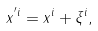Convert formula to latex. <formula><loc_0><loc_0><loc_500><loc_500>x ^ { ^ { \prime } i } = x ^ { i } + \xi ^ { i } ,</formula> 